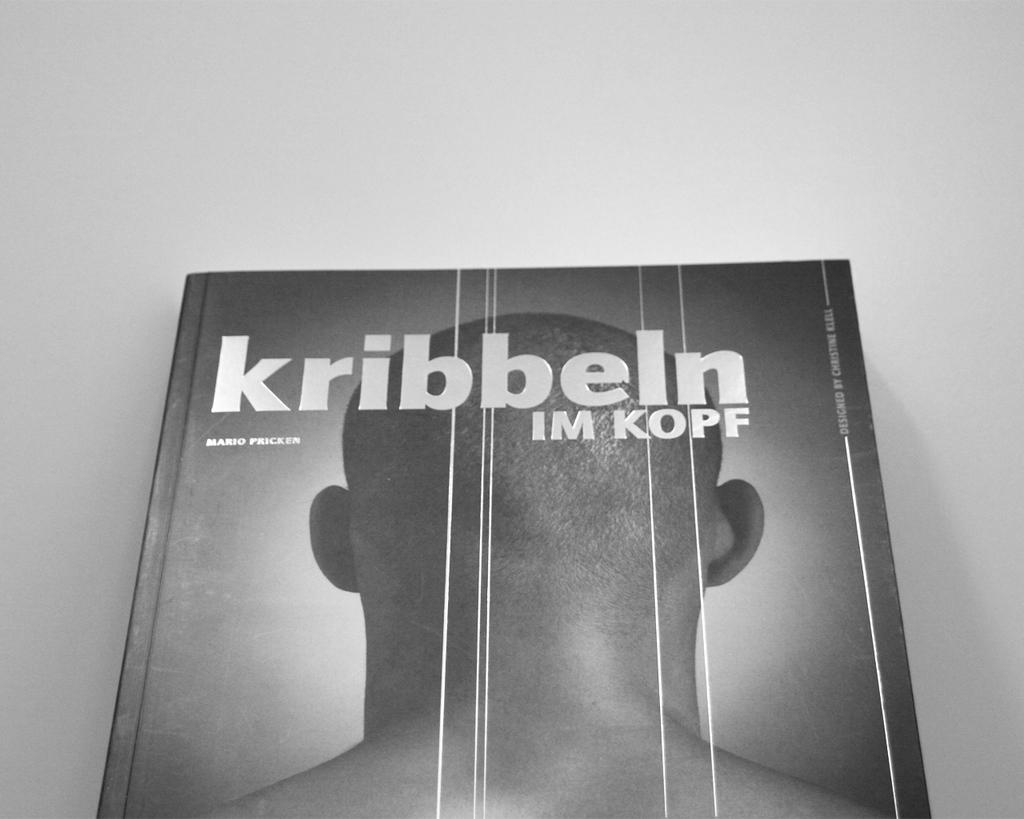What is the color scheme of the image? The image is black and white. What object can be seen in the image? There is a book in the image. What type of store is depicted in the image? There is no store present in the image; it only features a book in a black and white color scheme. How many coaches are visible in the image? There are no coaches present in the image. 